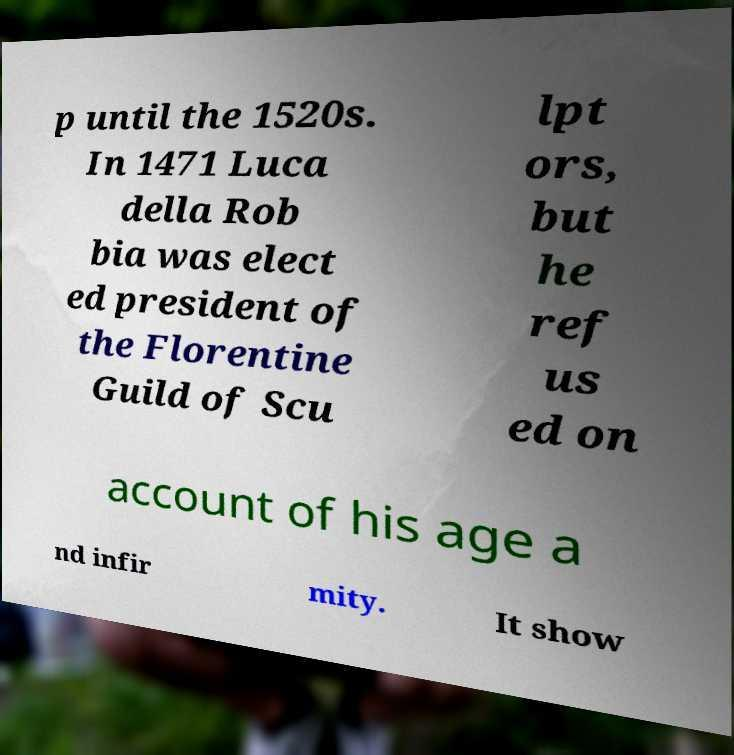Please read and relay the text visible in this image. What does it say? p until the 1520s. In 1471 Luca della Rob bia was elect ed president of the Florentine Guild of Scu lpt ors, but he ref us ed on account of his age a nd infir mity. It show 